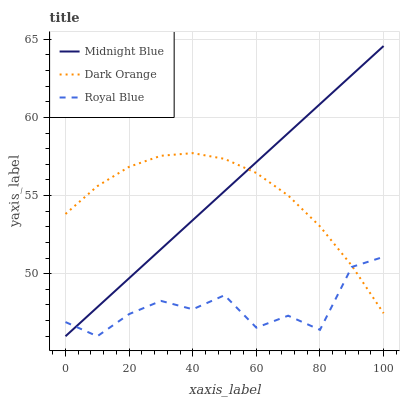Does Royal Blue have the minimum area under the curve?
Answer yes or no. Yes. Does Midnight Blue have the maximum area under the curve?
Answer yes or no. Yes. Does Midnight Blue have the minimum area under the curve?
Answer yes or no. No. Does Royal Blue have the maximum area under the curve?
Answer yes or no. No. Is Midnight Blue the smoothest?
Answer yes or no. Yes. Is Royal Blue the roughest?
Answer yes or no. Yes. Is Royal Blue the smoothest?
Answer yes or no. No. Is Midnight Blue the roughest?
Answer yes or no. No. Does Midnight Blue have the lowest value?
Answer yes or no. Yes. Does Midnight Blue have the highest value?
Answer yes or no. Yes. Does Royal Blue have the highest value?
Answer yes or no. No. Does Dark Orange intersect Royal Blue?
Answer yes or no. Yes. Is Dark Orange less than Royal Blue?
Answer yes or no. No. Is Dark Orange greater than Royal Blue?
Answer yes or no. No. 